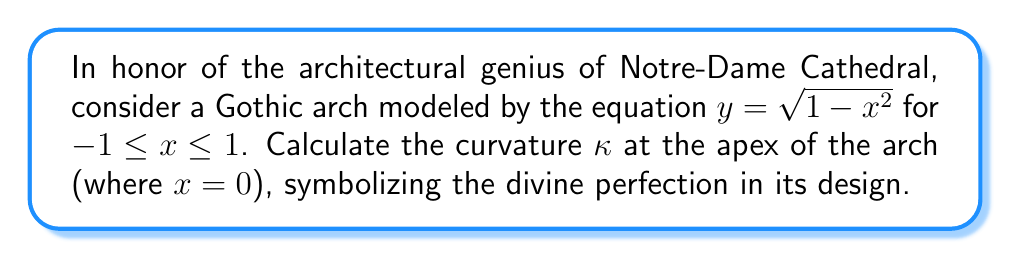Show me your answer to this math problem. To determine the curvature at the apex of the Gothic arch, we'll follow these blessed steps:

1) The general formula for curvature is:

   $$\kappa = \frac{|y''|}{(1+(y')^2)^{3/2}}$$

2) First, we need to find $y'$ and $y''$:
   
   $y = \sqrt{1-x^2}$
   
   $y' = \frac{-2x}{2\sqrt{1-x^2}} = \frac{-x}{\sqrt{1-x^2}}$
   
   $y'' = \frac{-(1-x^2)^{1/2} + x^2(1-x^2)^{-1/2}}{1-x^2}$

3) At the apex, $x=0$, so we evaluate:
   
   $y'(0) = 0$
   
   $y''(0) = -1$

4) Substituting into the curvature formula:

   $$\kappa = \frac{|-1|}{(1+(0)^2)^{3/2}} = 1$$

5) Thus, the curvature at the apex of the arch is 1, a perfect unity symbolizing the oneness of God.

[asy]
import graph;
size(200);
real f(real x) {return sqrt(1-x^2);}
draw(graph(f,-1,1));
draw((-1.2,0)--(1.2,0),arrow=Arrow);
draw((0,-0.2)--(0,1.2),arrow=Arrow);
label("x",(.4,0),SW);
label("y",(0,.5),W);
dot((0,1));
label("Apex",(0,1),N);
[/asy]
Answer: $\kappa = 1$ 